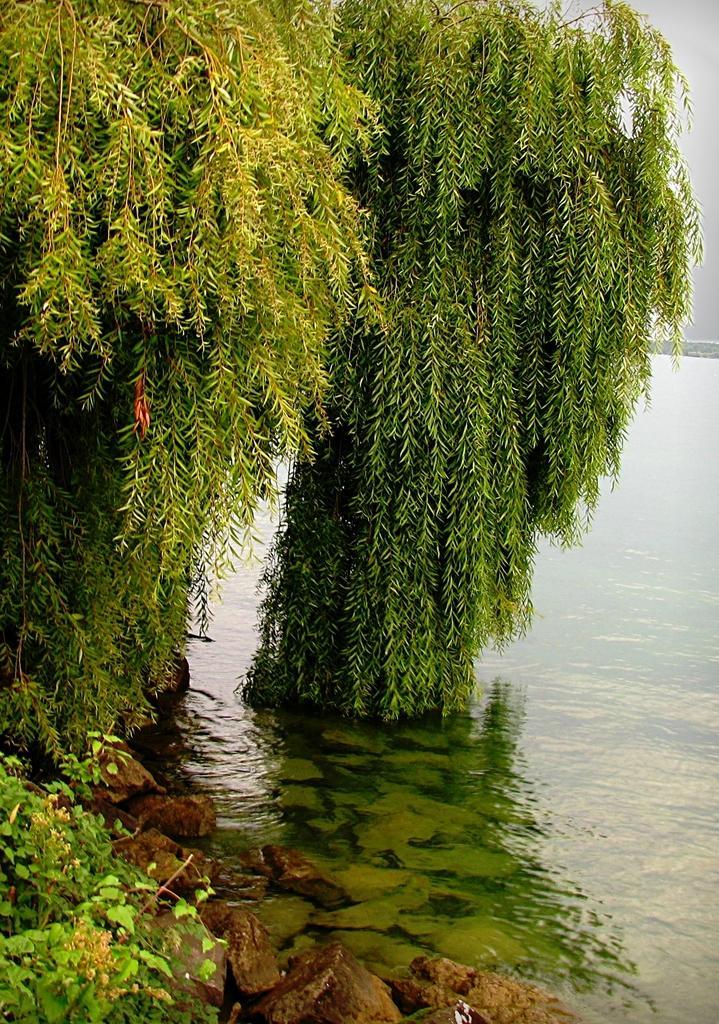Could you give a brief overview of what you see in this image? In this image as we can see there are some trees on the left side and there is a water on the right side of this image. 